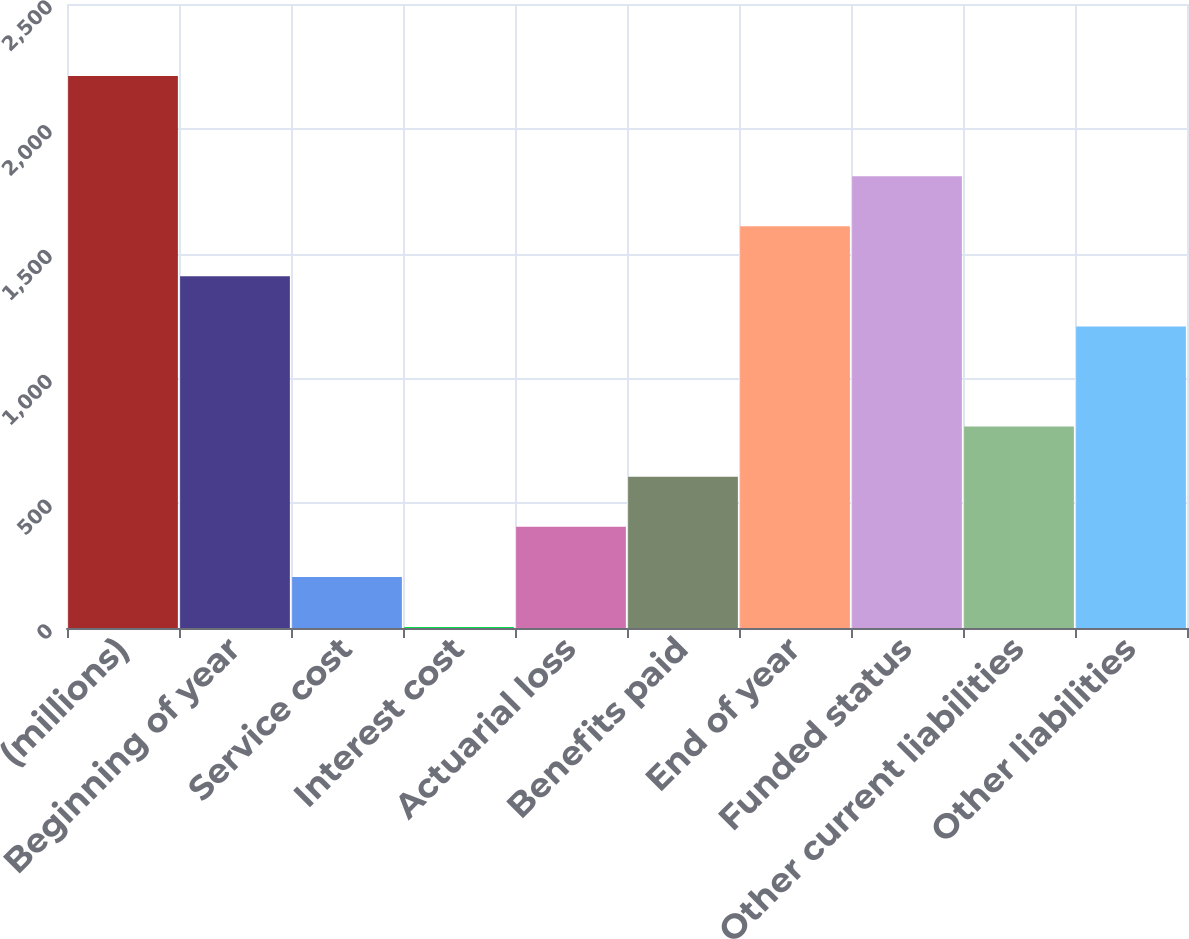Convert chart to OTSL. <chart><loc_0><loc_0><loc_500><loc_500><bar_chart><fcel>(millions)<fcel>Beginning of year<fcel>Service cost<fcel>Interest cost<fcel>Actuarial loss<fcel>Benefits paid<fcel>End of year<fcel>Funded status<fcel>Other current liabilities<fcel>Other liabilities<nl><fcel>2211.7<fcel>1408.9<fcel>204.7<fcel>4<fcel>405.4<fcel>606.1<fcel>1609.6<fcel>1810.3<fcel>806.8<fcel>1208.2<nl></chart> 